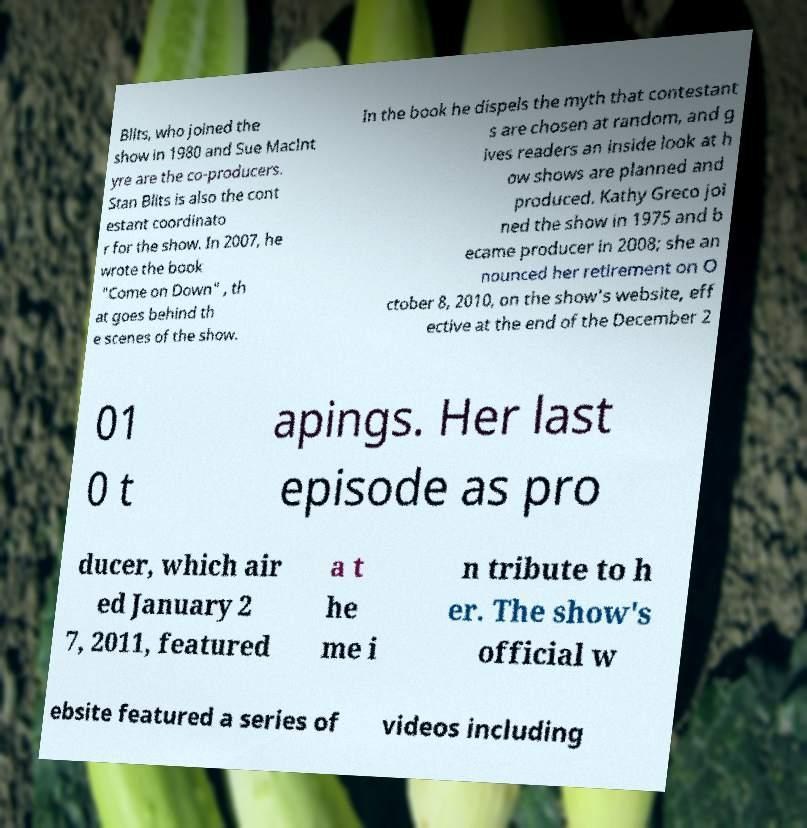Can you accurately transcribe the text from the provided image for me? Blits, who joined the show in 1980 and Sue MacInt yre are the co-producers. Stan Blits is also the cont estant coordinato r for the show. In 2007, he wrote the book "Come on Down" , th at goes behind th e scenes of the show. In the book he dispels the myth that contestant s are chosen at random, and g ives readers an inside look at h ow shows are planned and produced. Kathy Greco joi ned the show in 1975 and b ecame producer in 2008; she an nounced her retirement on O ctober 8, 2010, on the show's website, eff ective at the end of the December 2 01 0 t apings. Her last episode as pro ducer, which air ed January 2 7, 2011, featured a t he me i n tribute to h er. The show's official w ebsite featured a series of videos including 